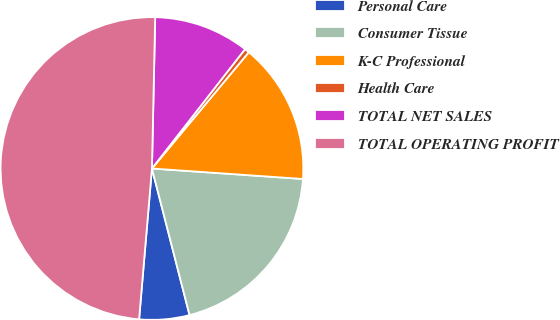Convert chart to OTSL. <chart><loc_0><loc_0><loc_500><loc_500><pie_chart><fcel>Personal Care<fcel>Consumer Tissue<fcel>K-C Professional<fcel>Health Care<fcel>TOTAL NET SALES<fcel>TOTAL OPERATING PROFIT<nl><fcel>5.35%<fcel>19.9%<fcel>15.05%<fcel>0.51%<fcel>10.2%<fcel>48.99%<nl></chart> 